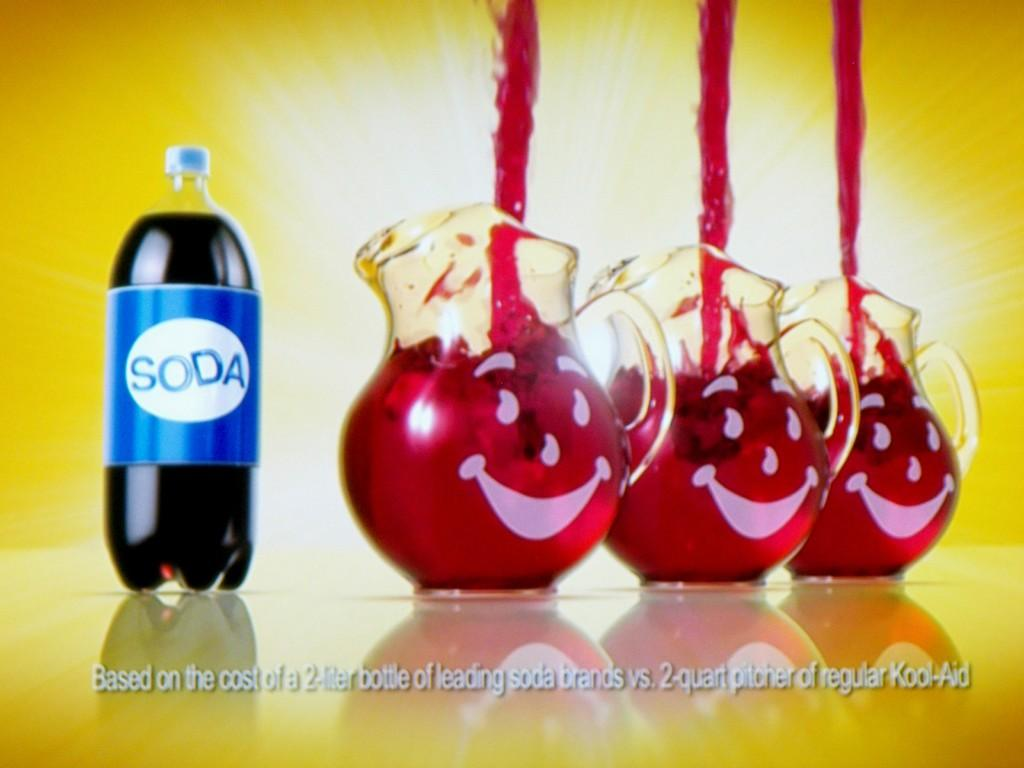How many jars are visible on the right side of the image? There are three jars on the right side of the image. What is written on the label of the bottle on the left side of the image? The label on the bottle on the left side of the image says "SODA." What type of fruit can be seen in the market in the image? There is no market or fruit present in the image; it only features three jars and a bottle with a "SODA" label. 